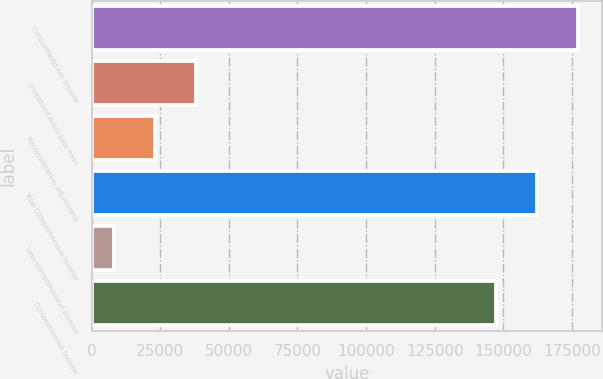<chart> <loc_0><loc_0><loc_500><loc_500><bar_chart><fcel>Consolidated net income<fcel>Unrealized (loss) gain from<fcel>Reclassification adjustment<fcel>Total Comprehensive Income<fcel>Less comprehensive income<fcel>Comprehensive income<nl><fcel>177062<fcel>37869<fcel>23068<fcel>162261<fcel>8267<fcel>147460<nl></chart> 